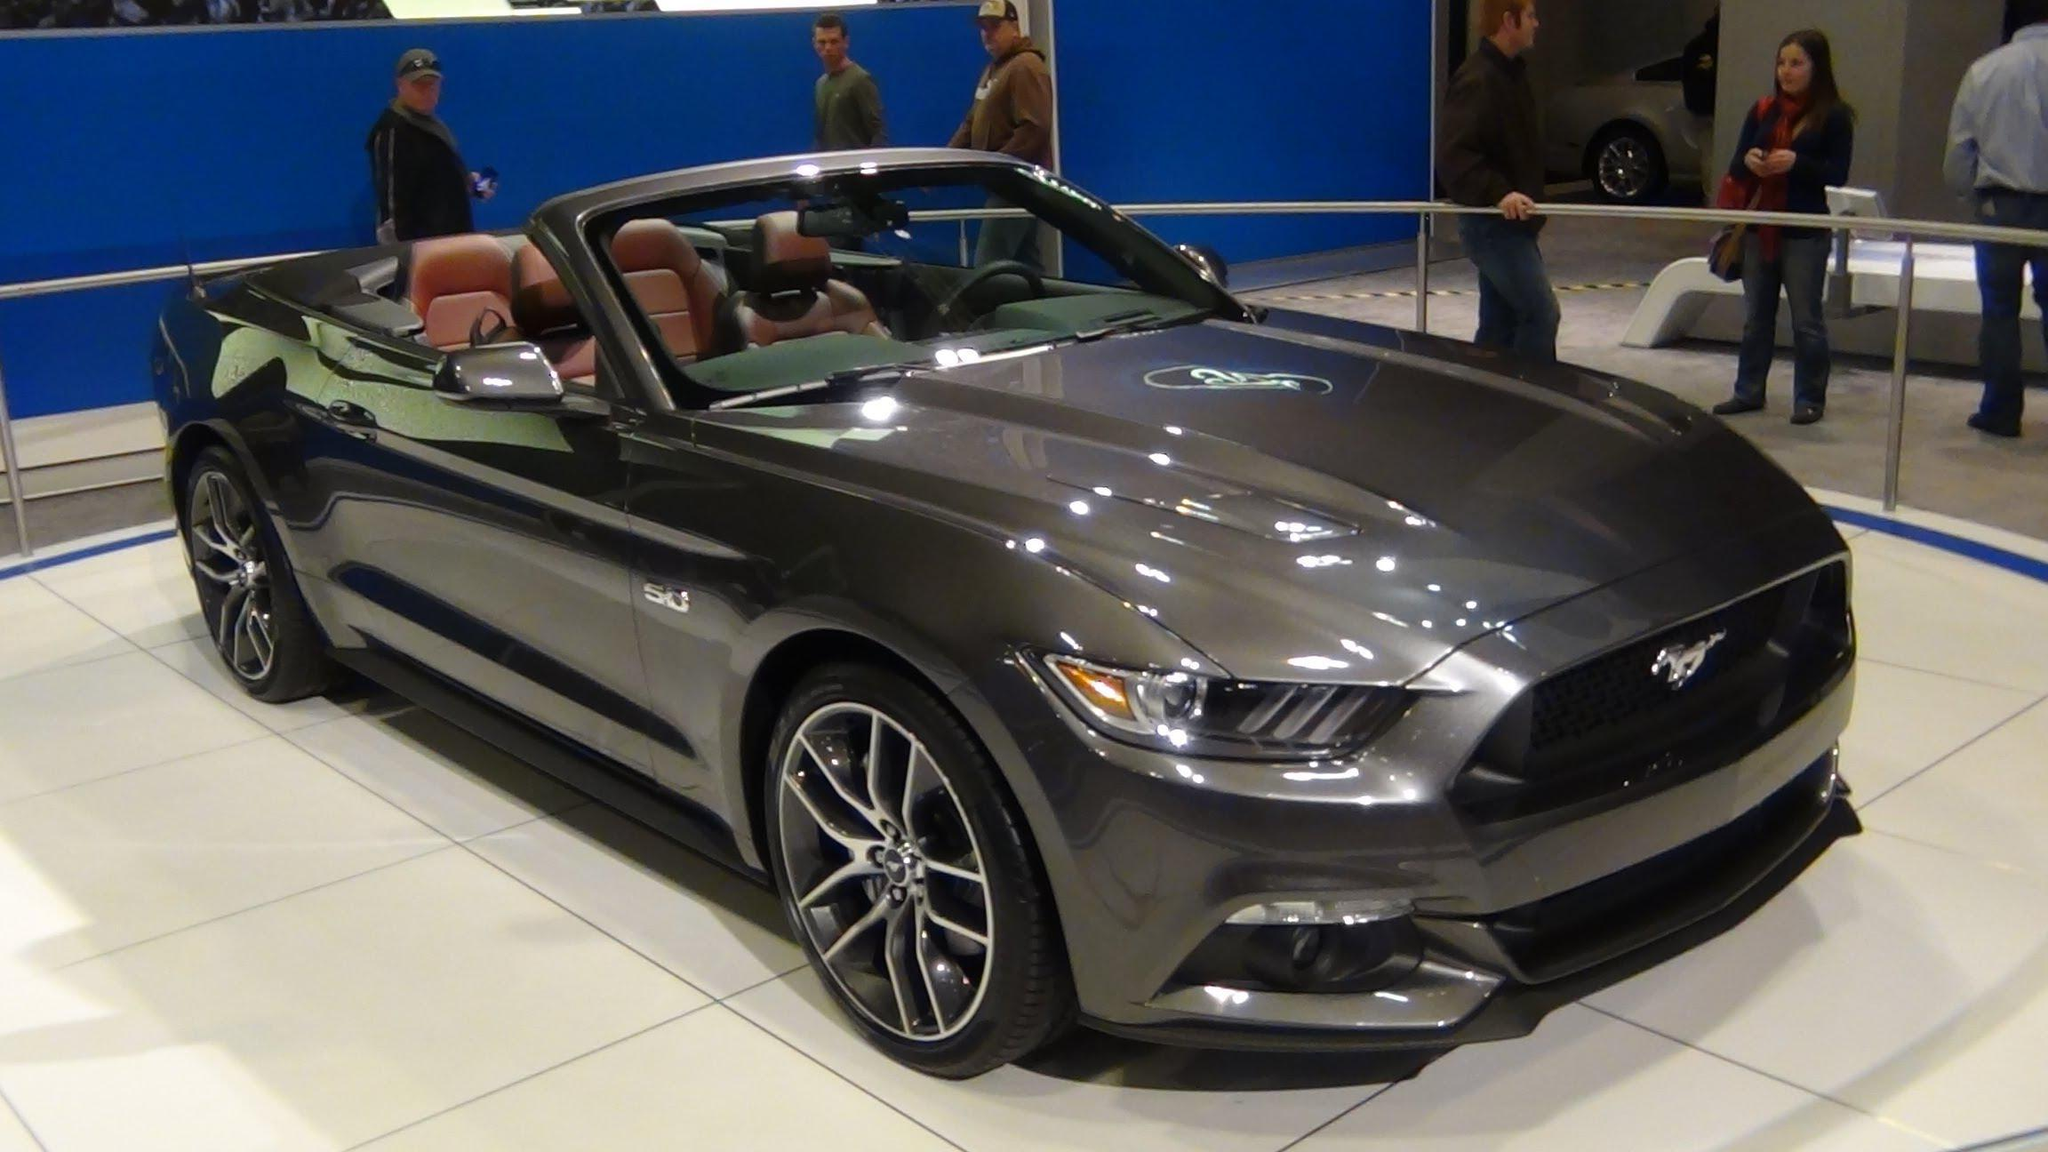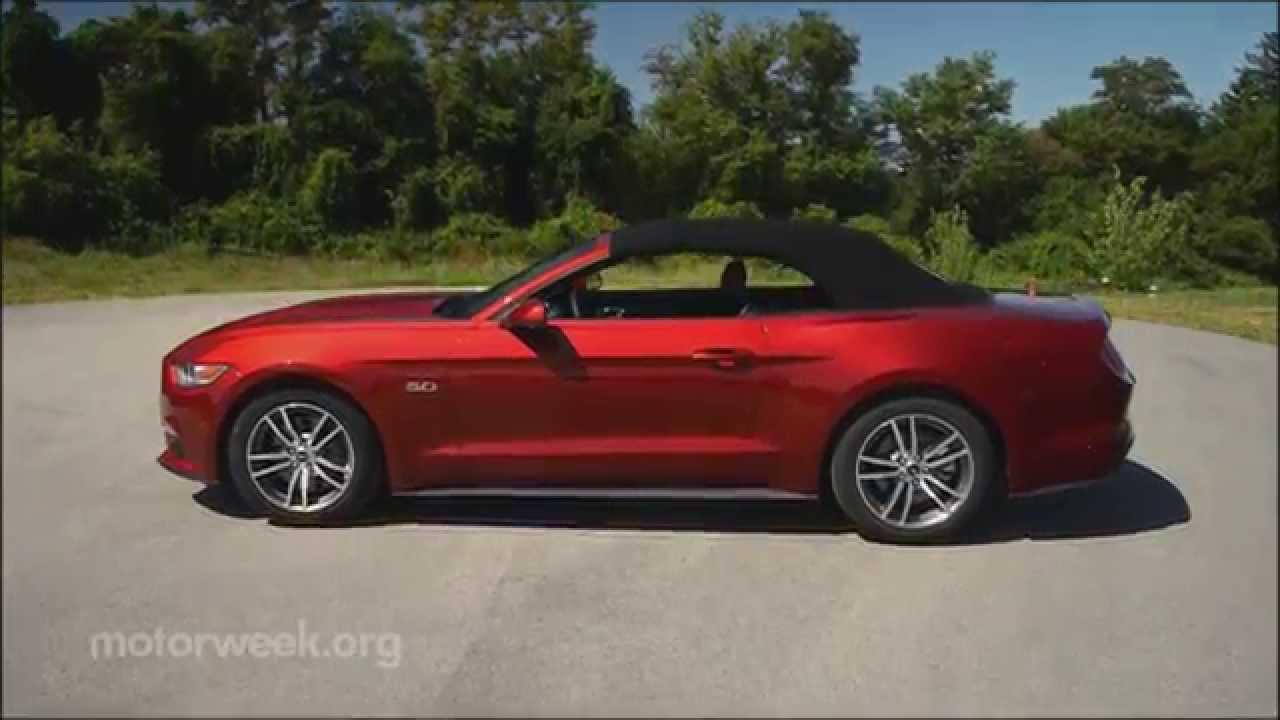The first image is the image on the left, the second image is the image on the right. For the images shown, is this caption "You can't actually see any of the brakes light areas." true? Answer yes or no. Yes. The first image is the image on the left, the second image is the image on the right. Examine the images to the left and right. Is the description "One of the convertibles doesn't have the top removed." accurate? Answer yes or no. Yes. 